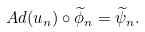<formula> <loc_0><loc_0><loc_500><loc_500>A d ( u _ { n } ) \circ \widetilde { \phi } _ { n } = \widetilde { \psi } _ { n } .</formula> 